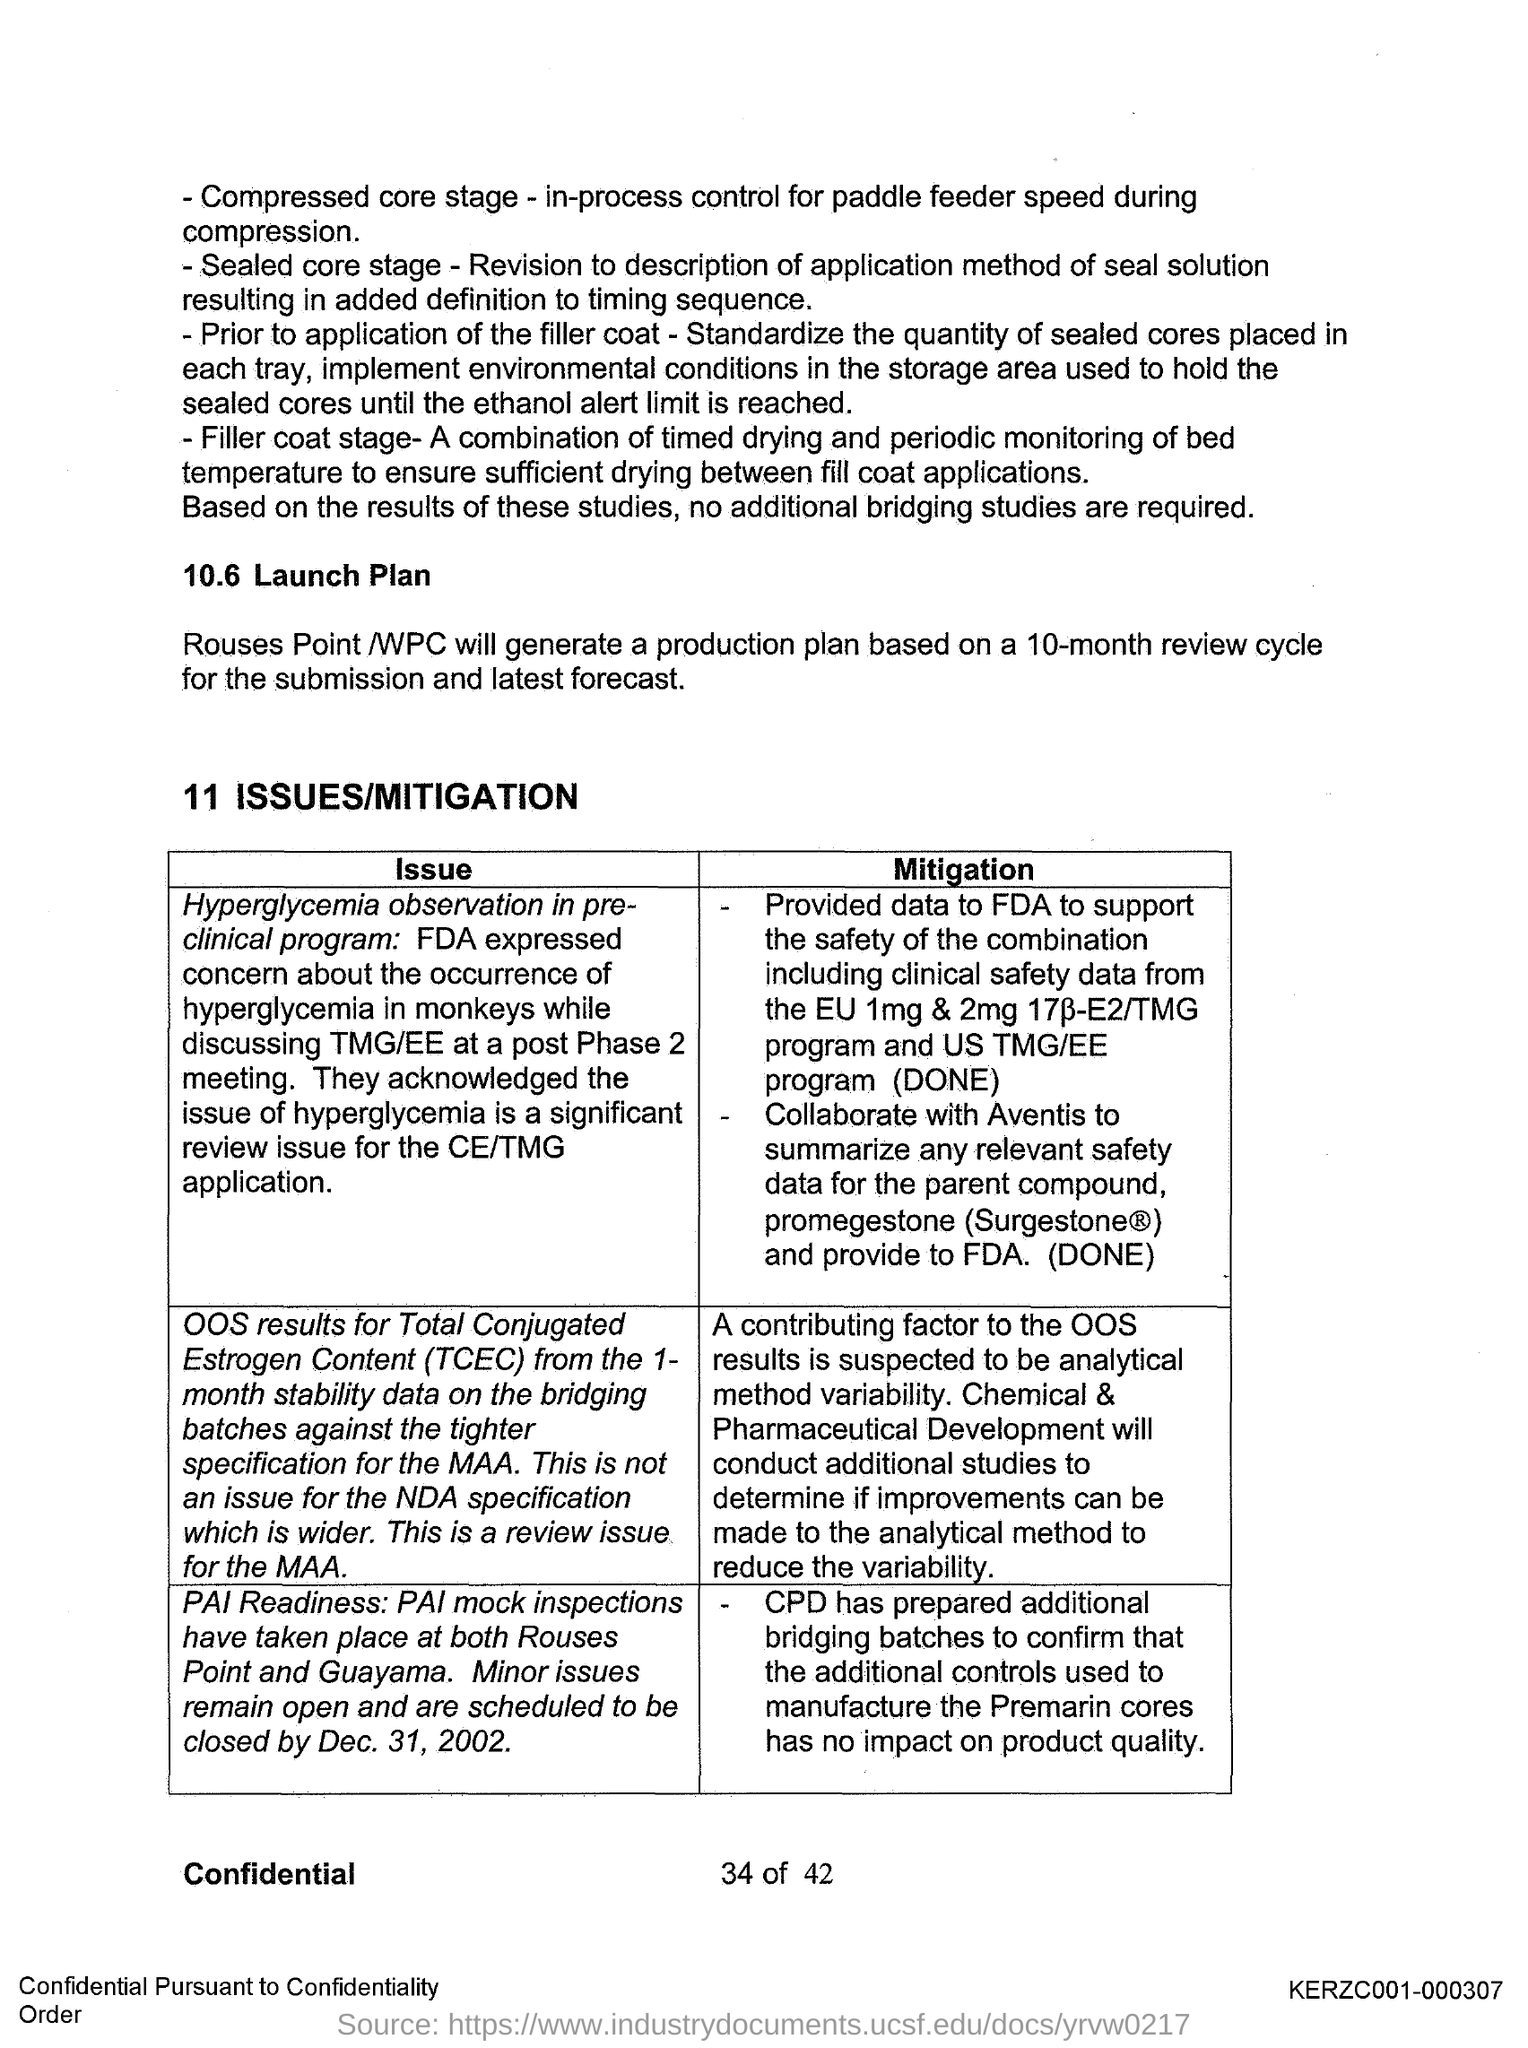What is the full form of tcec?
Your response must be concise. Total Conjugated Estrogen Content. 